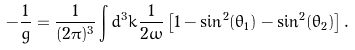<formula> <loc_0><loc_0><loc_500><loc_500>- \frac { 1 } { g } = \frac { 1 } { ( 2 \pi ) ^ { 3 } } \int d ^ { 3 } k \frac { 1 } { 2 \omega } \left [ 1 - \sin ^ { 2 } ( \theta _ { 1 } ) - \sin ^ { 2 } ( \theta _ { 2 } ) \right ] .</formula> 